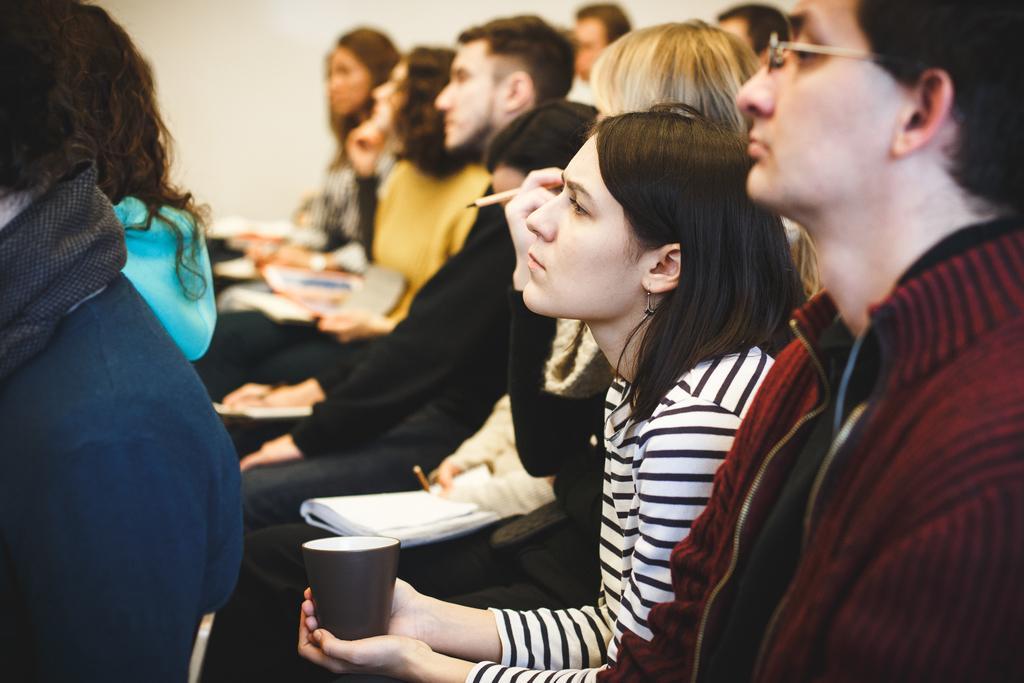Could you give a brief overview of what you see in this image? In this image, there are some persons wearing clothes and sitting together. There is a person at the bottom of the image holding a coffee cup with her hands. There is a person on the right side of the image wearing spectacles. 